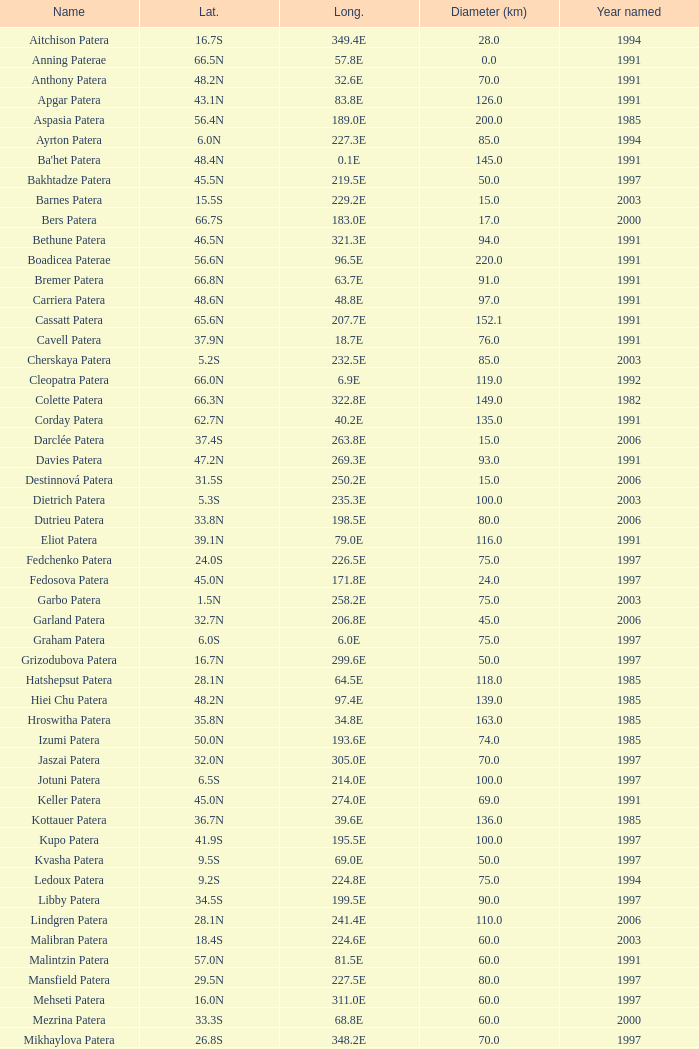What is Longitude, when Name is Raskova Paterae? 222.8E. 